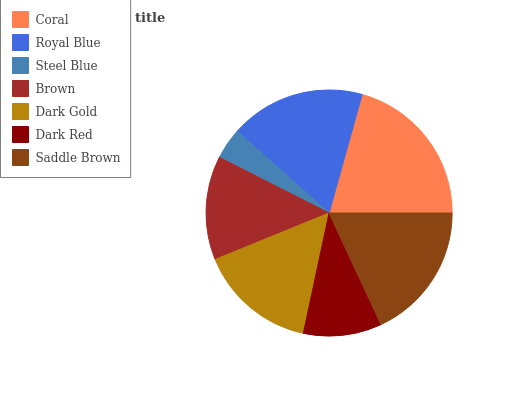Is Steel Blue the minimum?
Answer yes or no. Yes. Is Coral the maximum?
Answer yes or no. Yes. Is Royal Blue the minimum?
Answer yes or no. No. Is Royal Blue the maximum?
Answer yes or no. No. Is Coral greater than Royal Blue?
Answer yes or no. Yes. Is Royal Blue less than Coral?
Answer yes or no. Yes. Is Royal Blue greater than Coral?
Answer yes or no. No. Is Coral less than Royal Blue?
Answer yes or no. No. Is Dark Gold the high median?
Answer yes or no. Yes. Is Dark Gold the low median?
Answer yes or no. Yes. Is Royal Blue the high median?
Answer yes or no. No. Is Royal Blue the low median?
Answer yes or no. No. 